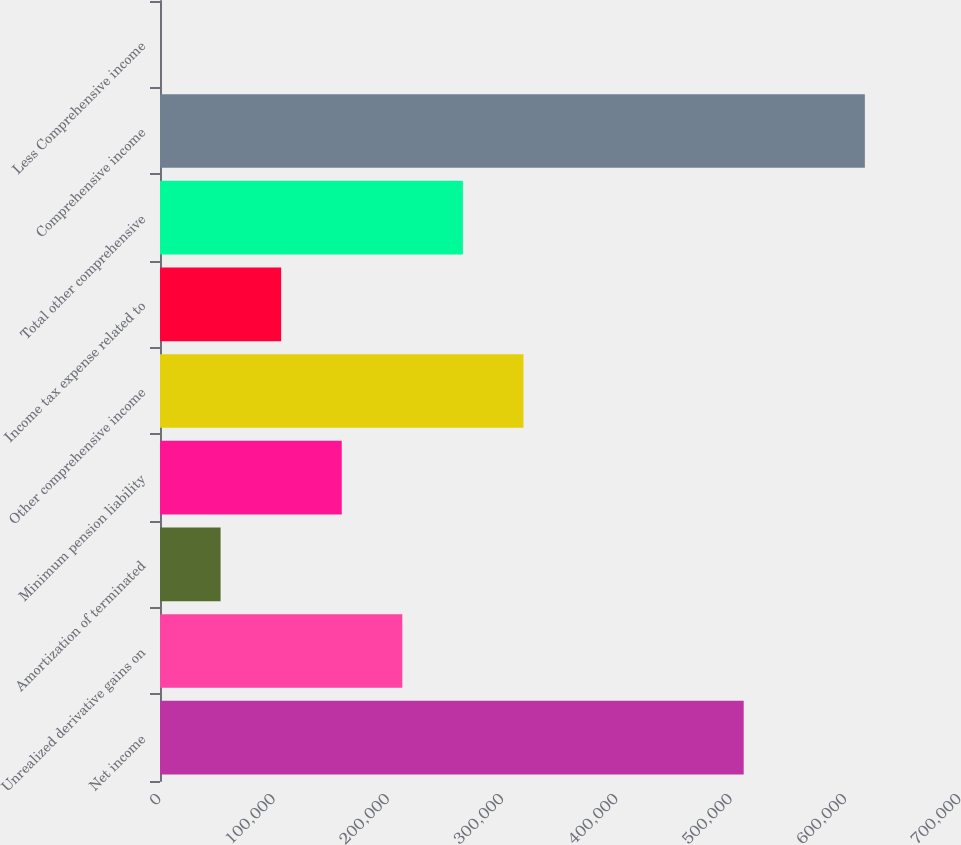Convert chart. <chart><loc_0><loc_0><loc_500><loc_500><bar_chart><fcel>Net income<fcel>Unrealized derivative gains on<fcel>Amortization of terminated<fcel>Minimum pension liability<fcel>Other comprehensive income<fcel>Income tax expense related to<fcel>Total other comprehensive<fcel>Comprehensive income<fcel>Less Comprehensive income<nl><fcel>510733<fcel>212032<fcel>53009.4<fcel>159024<fcel>318047<fcel>106017<fcel>265039<fcel>616748<fcel>1.92<nl></chart> 